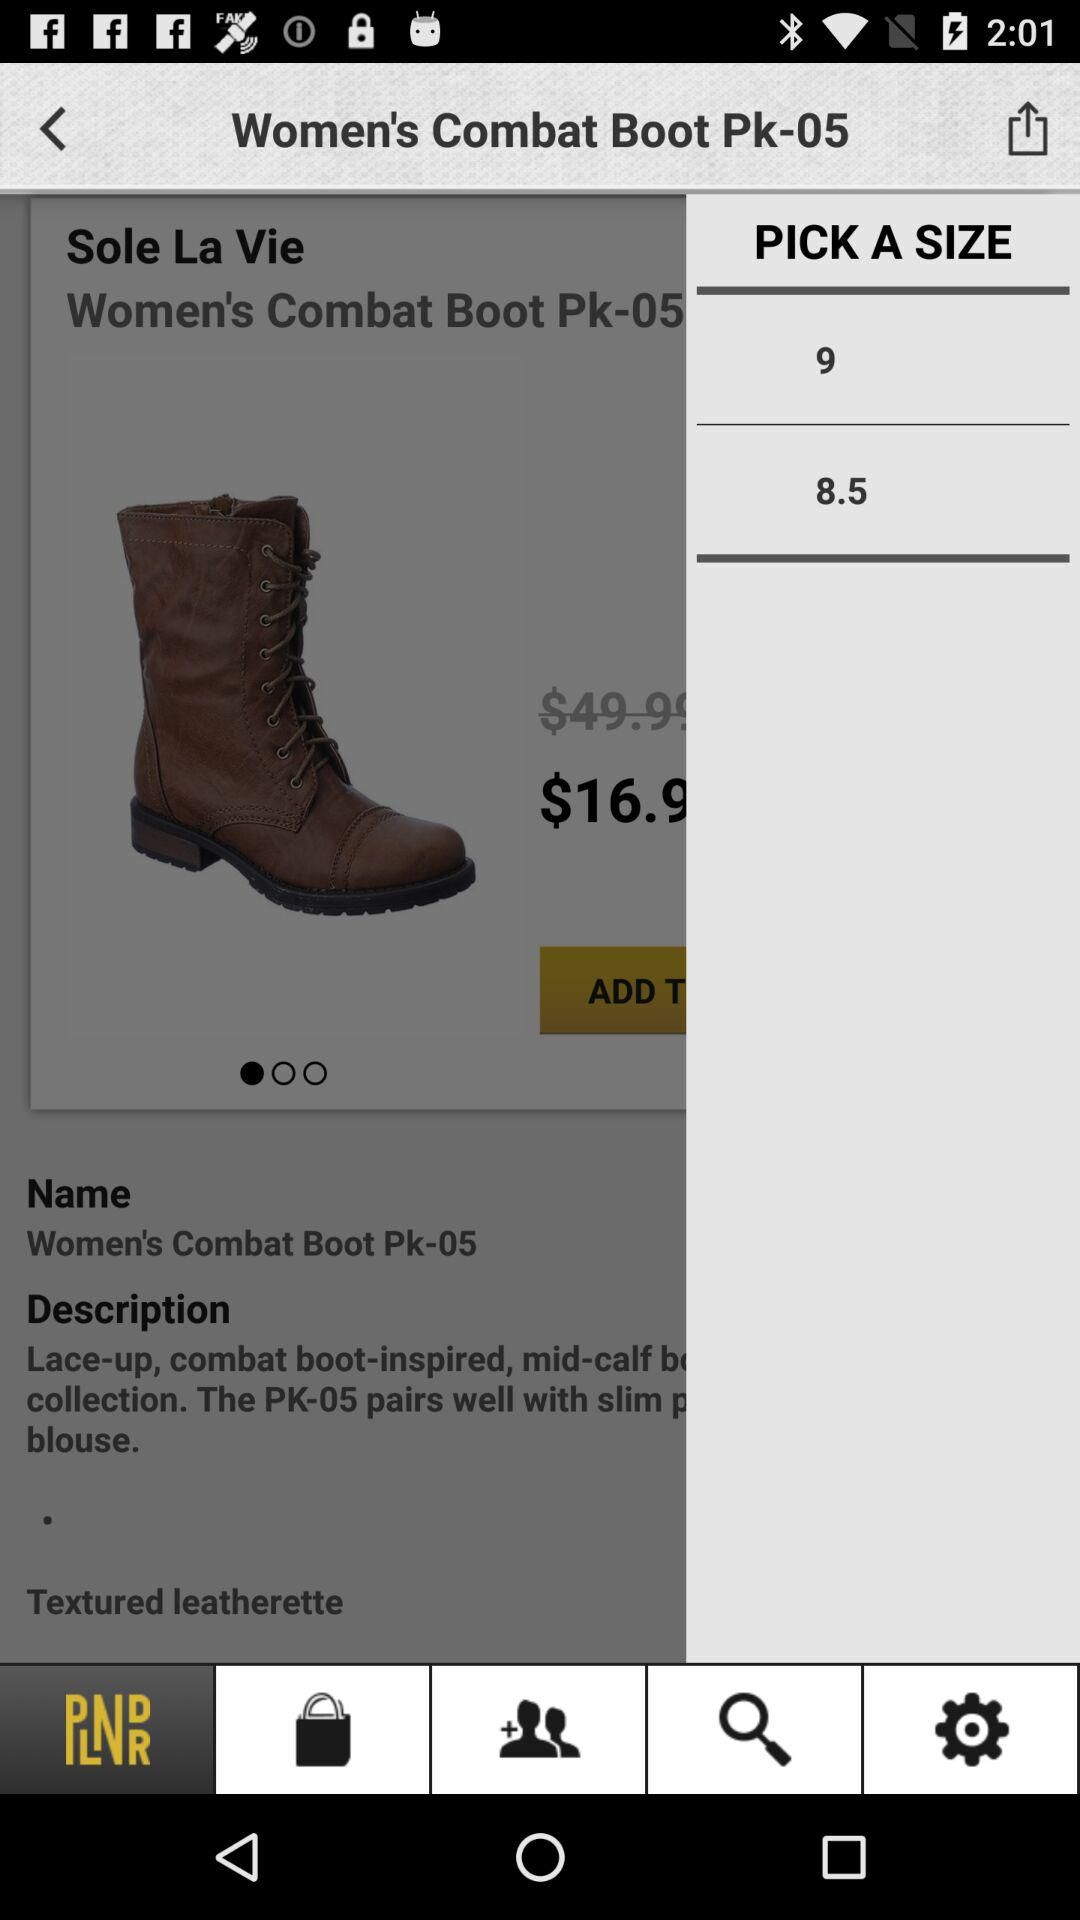How much is the sale price of this item?
Answer the question using a single word or phrase. $16.9 